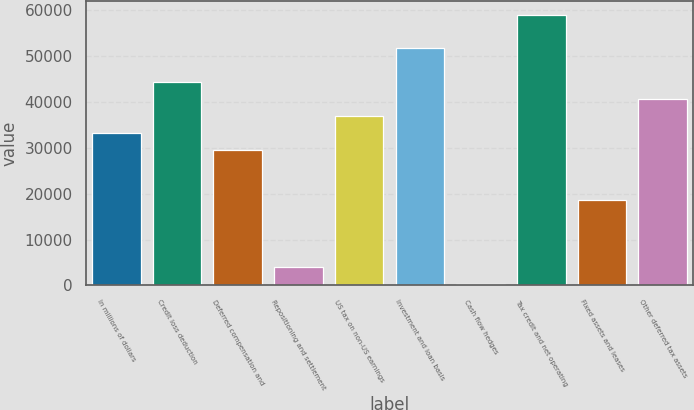<chart> <loc_0><loc_0><loc_500><loc_500><bar_chart><fcel>In millions of dollars<fcel>Credit loss deduction<fcel>Deferred compensation and<fcel>Repositioning and settlement<fcel>US tax on non-US earnings<fcel>Investment and loan basis<fcel>Cash flow hedges<fcel>Tax credit and net operating<fcel>Fixed assets and leases<fcel>Other deferred tax assets<nl><fcel>33272.7<fcel>44283.6<fcel>29602.4<fcel>3910.3<fcel>36943<fcel>51624.2<fcel>240<fcel>58964.8<fcel>18591.5<fcel>40613.3<nl></chart> 